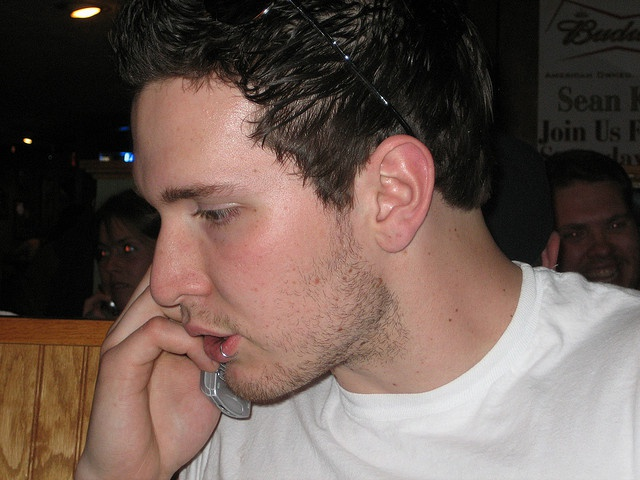Describe the objects in this image and their specific colors. I can see people in black, gray, lightgray, and darkgray tones, people in black, gray, and darkgray tones, people in black, maroon, and gray tones, people in black, maroon, and brown tones, and cell phone in black, gray, and darkgray tones in this image. 